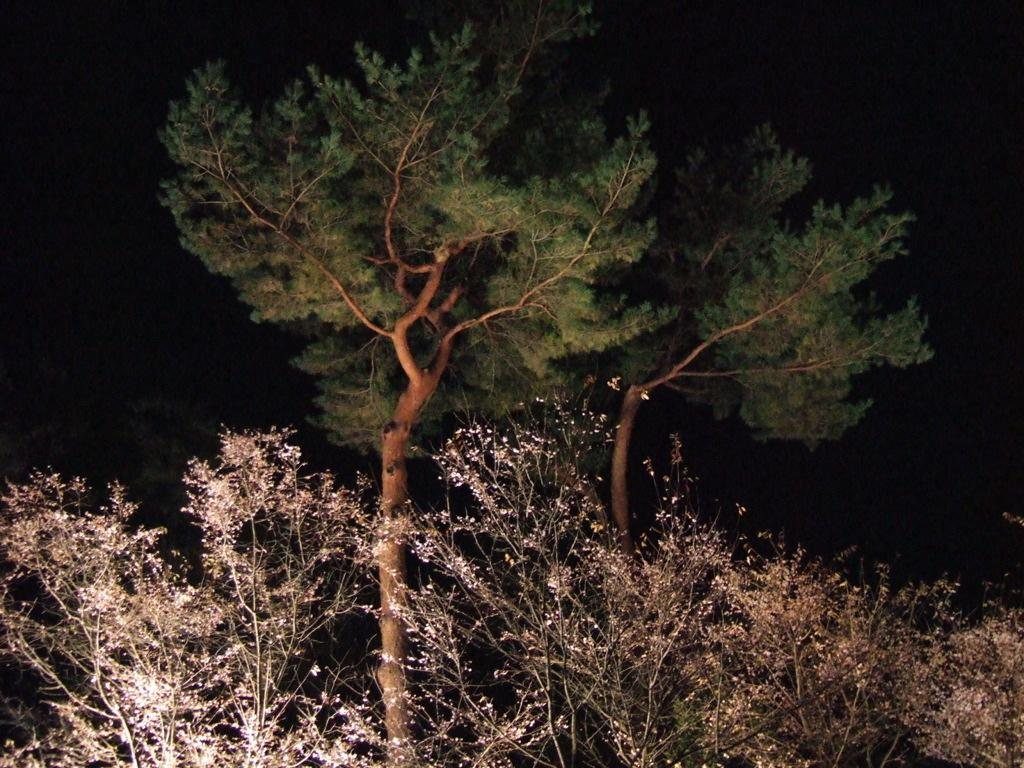What type of vegetation is visible in the image? There are trees in the image. What is the color of the background in the image? The background of the image is dark. What type of cemetery can be seen in the image? There is no cemetery present in the image; it features trees and a dark background. What is the beam used for in the image? There is no beam present in the image. 